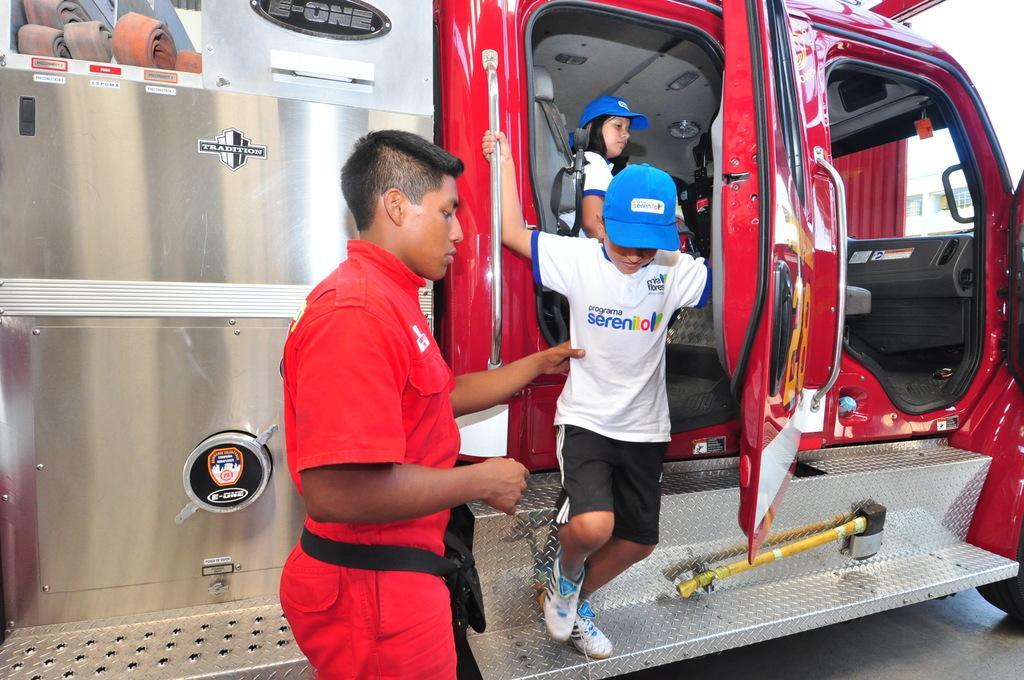Describe this image in one or two sentences. In this picture there is a van from which a little boy is getting down and an other in front of him is holding him and there is an other lady in the van. 